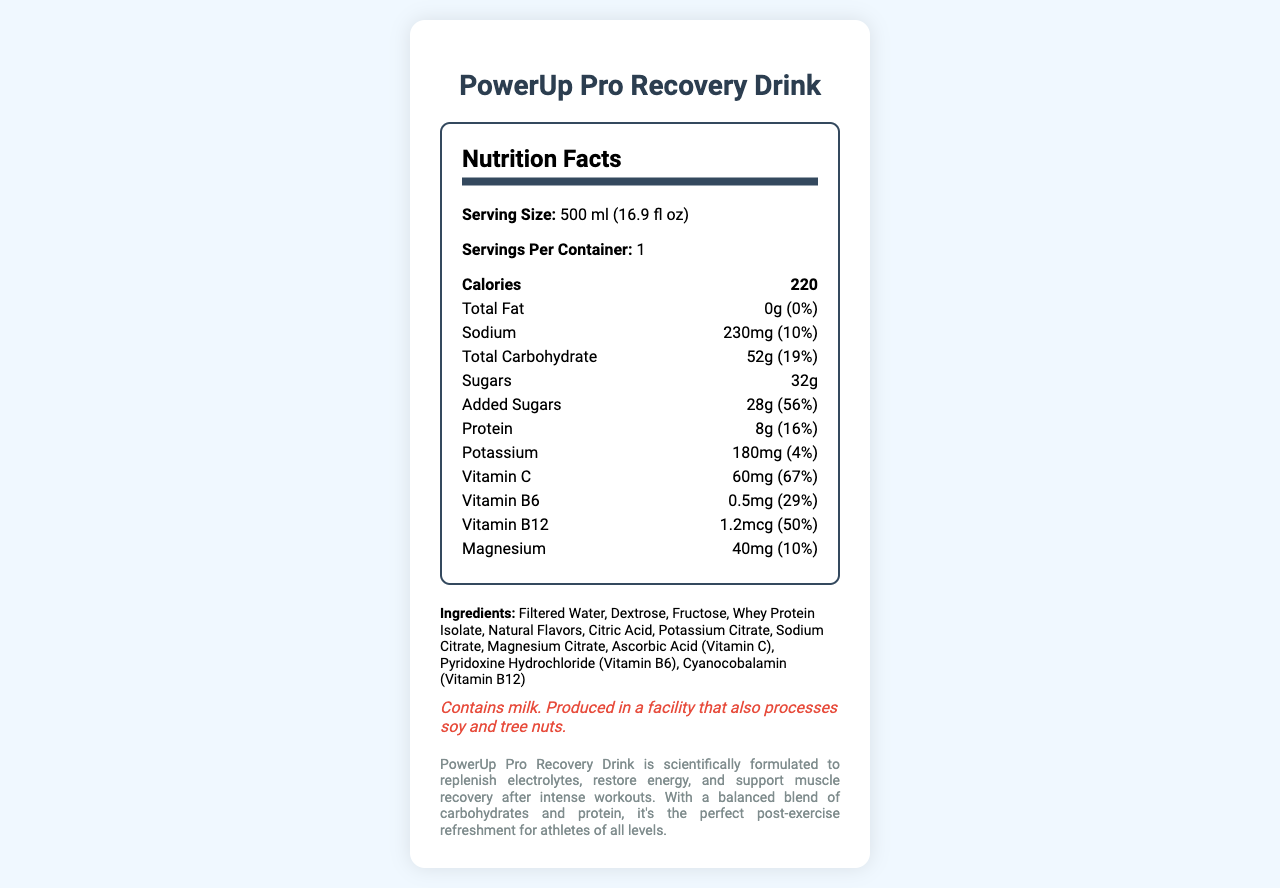what is the serving size of PowerUp Pro Recovery Drink? The serving size mentioned in the nutrition facts is 500 ml (16.9 fl oz).
Answer: 500 ml (16.9 fl oz) how many calories are in one serving of PowerUp Pro Recovery Drink? The nutrition facts state that there are 220 calories in one serving.
Answer: 220 what is the daily value percentage of added sugars in this drink? According to the nutrition facts, the added sugars amount to 28g, which is 56% of the daily value.
Answer: 56% how many grams of protein does the drink contain? The protein content listed in the nutrition facts is 8 grams.
Answer: 8g what are the first three ingredients listed? The first three ingredients listed are Filtered Water, Dextrose, and Fructose.
Answer: Filtered Water, Dextrose, Fructose what is the primary purpose of PowerUp Pro Recovery Drink according to the product description? The product description states that the drink is formulated to replenish electrolytes, restore energy, and support muscle recovery after workouts.
Answer: To replenish electrolytes, restore energy, and support muscle recovery after intense workouts what is the amount of sodium in one serving, and what percentage of the daily value does it represent? The sodium content is 230mg, which represents 10% of the daily value.
Answer: 230mg, 10% how much Vitamin C is in one serving, and what percentage of the daily value does it cover? One serving contains 60mg of Vitamin C, covering 67% of the daily value.
Answer: 60mg, 67% which of the following is an ingredient in PowerUp Pro Recovery Drink?
I. Fructose
II. Glycine
III. Citric Acid
IV. Ascorbic Acid (Vitamin C) The ingredients list includes Fructose, Citric Acid, and Ascorbic Acid (Vitamin C), but not Glycine.
Answer: I, III, IV what allergens does PowerUp Pro Recovery Drink contain? The allergen information states that the drink contains milk.
Answer: Milk does the PowerUp Pro Recovery Drink contain any total fat? The nutrition facts indicate that it has 0g of total fat.
Answer: No describe the main idea of this document The document contains a comprehensive listing of the nutrients per serving, ingredients, allergen warnings, and product description, emphasizing the drink's role in muscle recovery and energy replenishment.
Answer: The document provides detailed nutrition facts, ingredient information, and product description for PowerUp Pro Recovery Drink, highlighting its benefits for athletes and its nutritional content. what is the daily value percentage of protein in one serving? The document indicates that the protein in one serving makes up 16% of the daily value.
Answer: 16% how is the product placement of PowerUp Pro Recovery Drink described in the document? The product is described as being strategically placed in the athlete's locker, highlighting its essential role naturally in the athlete's gear.
Answer: Strategically placed in the athlete's locker, fitting seamlessly into the scene. can you determine the exact manufacturing date of PowerUp Pro Recovery Drink from this document? The document does not include any information about the manufacturing date of the drink.
Answer: Not enough information is the PowerUp Pro Recovery Drink suitable for someone allergic to soy? The drink is produced in a facility that also processes soy, as indicated in the allergen information.
Answer: No 